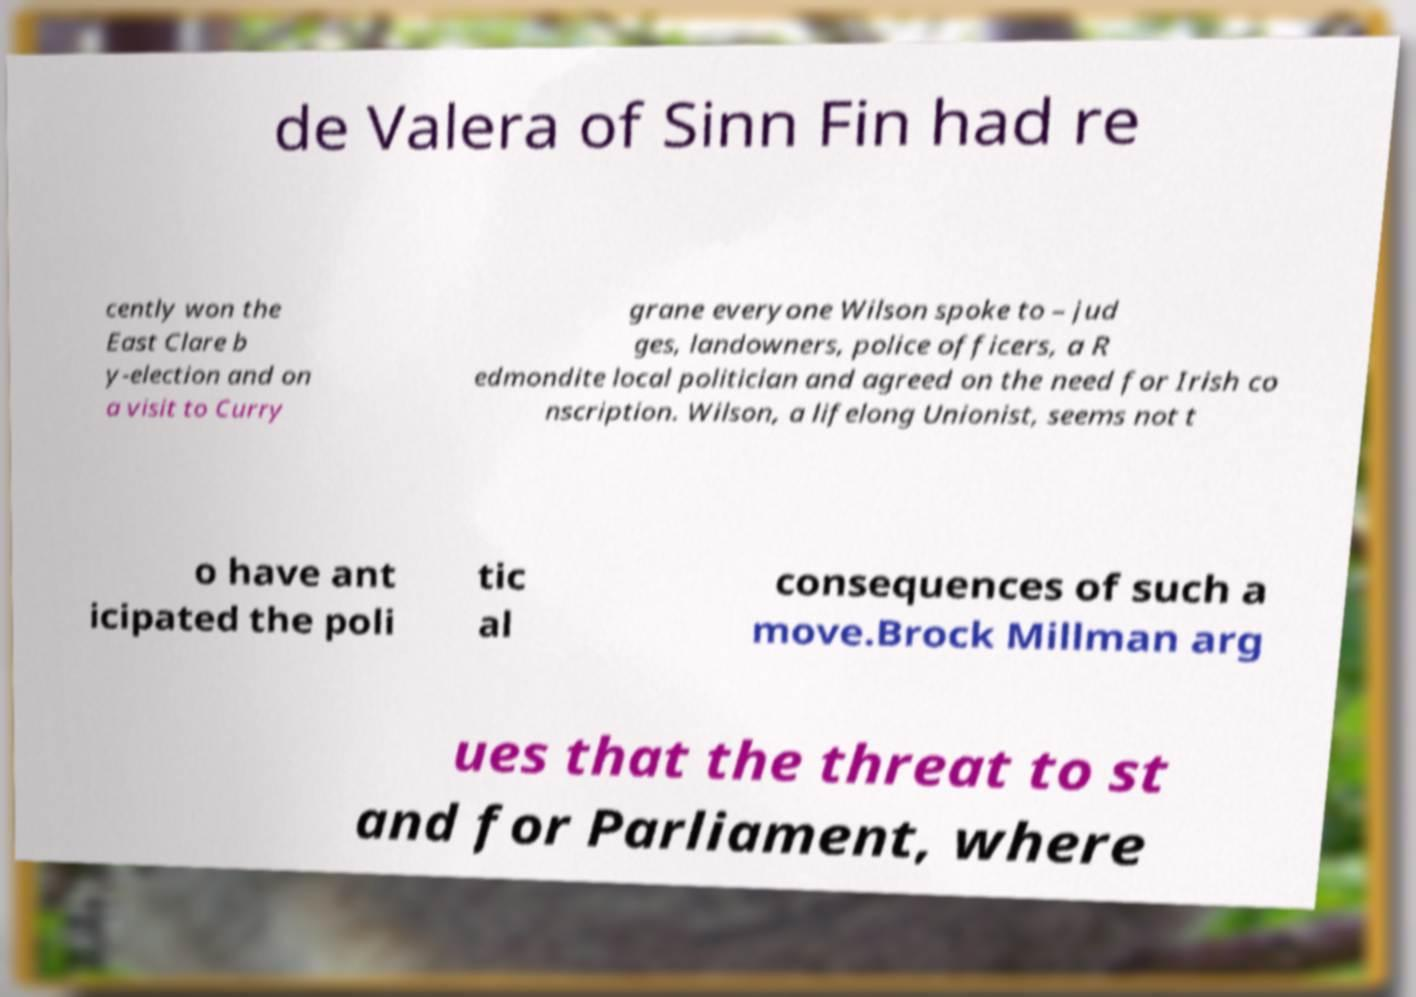There's text embedded in this image that I need extracted. Can you transcribe it verbatim? de Valera of Sinn Fin had re cently won the East Clare b y-election and on a visit to Curry grane everyone Wilson spoke to – jud ges, landowners, police officers, a R edmondite local politician and agreed on the need for Irish co nscription. Wilson, a lifelong Unionist, seems not t o have ant icipated the poli tic al consequences of such a move.Brock Millman arg ues that the threat to st and for Parliament, where 